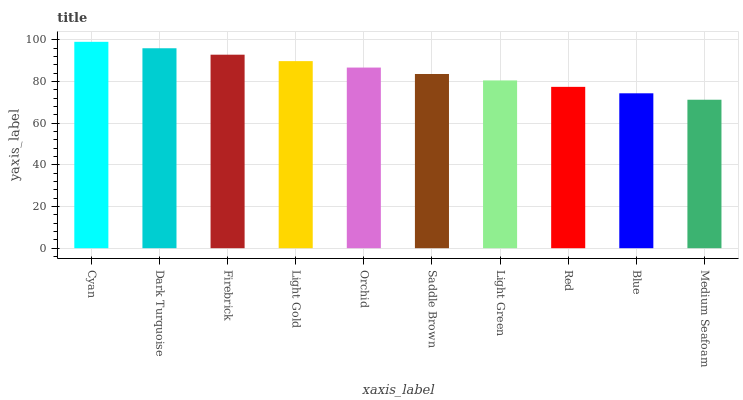Is Dark Turquoise the minimum?
Answer yes or no. No. Is Dark Turquoise the maximum?
Answer yes or no. No. Is Cyan greater than Dark Turquoise?
Answer yes or no. Yes. Is Dark Turquoise less than Cyan?
Answer yes or no. Yes. Is Dark Turquoise greater than Cyan?
Answer yes or no. No. Is Cyan less than Dark Turquoise?
Answer yes or no. No. Is Orchid the high median?
Answer yes or no. Yes. Is Saddle Brown the low median?
Answer yes or no. Yes. Is Saddle Brown the high median?
Answer yes or no. No. Is Medium Seafoam the low median?
Answer yes or no. No. 